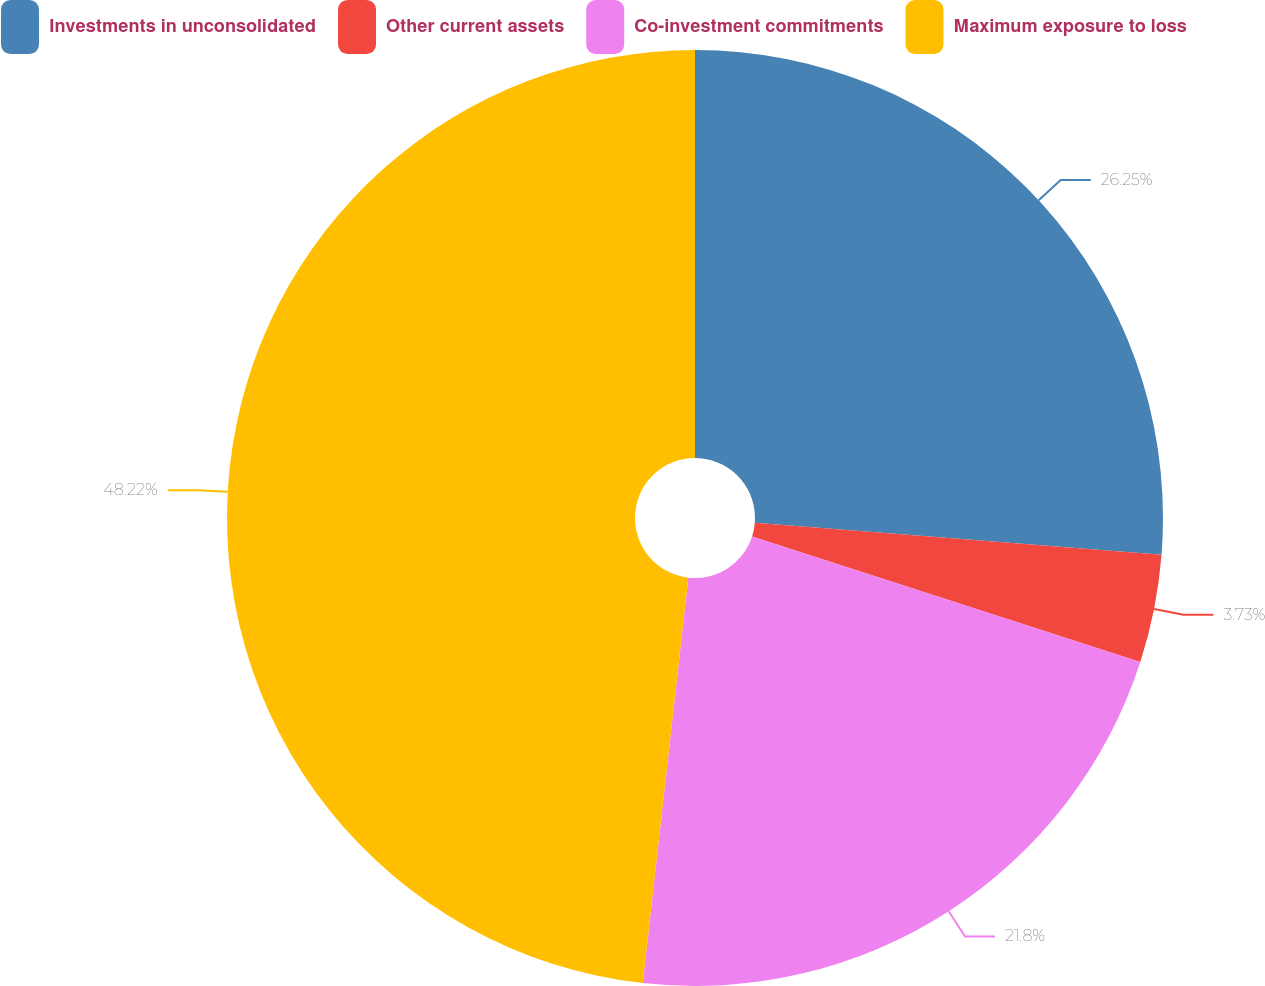Convert chart. <chart><loc_0><loc_0><loc_500><loc_500><pie_chart><fcel>Investments in unconsolidated<fcel>Other current assets<fcel>Co-investment commitments<fcel>Maximum exposure to loss<nl><fcel>26.25%<fcel>3.73%<fcel>21.8%<fcel>48.22%<nl></chart> 